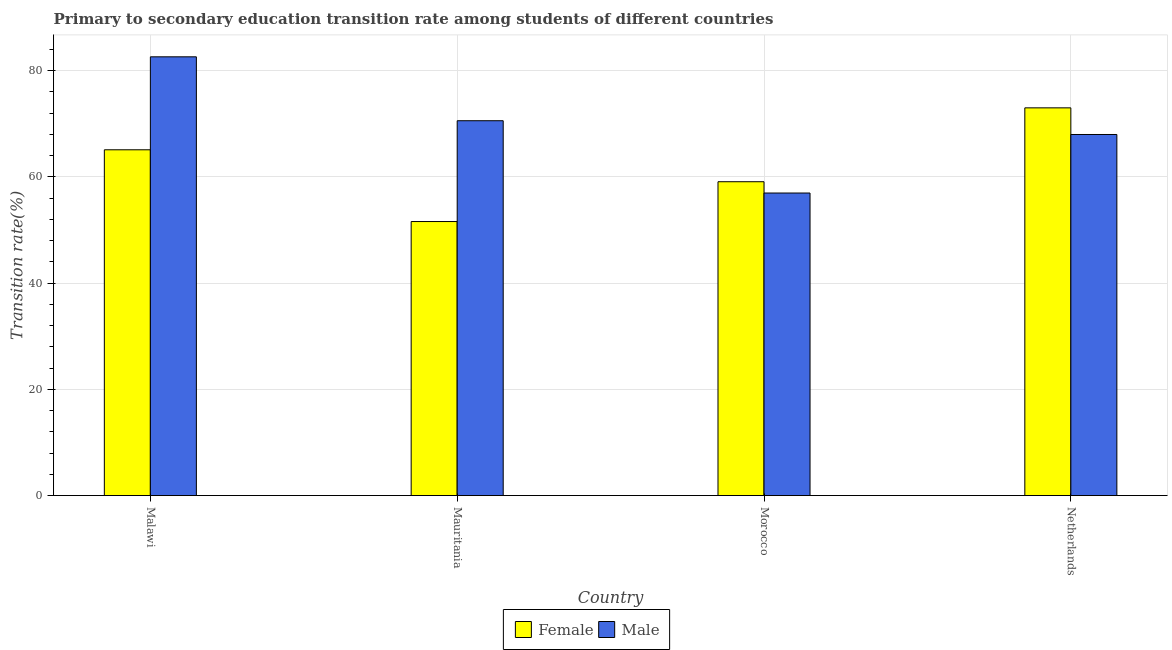How many different coloured bars are there?
Your answer should be compact. 2. Are the number of bars on each tick of the X-axis equal?
Offer a terse response. Yes. How many bars are there on the 2nd tick from the right?
Give a very brief answer. 2. What is the label of the 1st group of bars from the left?
Offer a terse response. Malawi. In how many cases, is the number of bars for a given country not equal to the number of legend labels?
Ensure brevity in your answer.  0. What is the transition rate among female students in Mauritania?
Keep it short and to the point. 51.59. Across all countries, what is the maximum transition rate among female students?
Ensure brevity in your answer.  73. Across all countries, what is the minimum transition rate among male students?
Provide a succinct answer. 56.96. In which country was the transition rate among female students maximum?
Offer a very short reply. Netherlands. In which country was the transition rate among male students minimum?
Your answer should be compact. Morocco. What is the total transition rate among female students in the graph?
Keep it short and to the point. 248.77. What is the difference between the transition rate among male students in Malawi and that in Mauritania?
Your answer should be compact. 12.03. What is the difference between the transition rate among female students in Netherlands and the transition rate among male students in Morocco?
Keep it short and to the point. 16.04. What is the average transition rate among male students per country?
Keep it short and to the point. 69.53. What is the difference between the transition rate among male students and transition rate among female students in Netherlands?
Keep it short and to the point. -5.02. In how many countries, is the transition rate among male students greater than 4 %?
Your answer should be very brief. 4. What is the ratio of the transition rate among female students in Malawi to that in Netherlands?
Make the answer very short. 0.89. Is the transition rate among female students in Malawi less than that in Morocco?
Your response must be concise. No. Is the difference between the transition rate among female students in Mauritania and Netherlands greater than the difference between the transition rate among male students in Mauritania and Netherlands?
Provide a short and direct response. No. What is the difference between the highest and the second highest transition rate among female students?
Give a very brief answer. 7.9. What is the difference between the highest and the lowest transition rate among male students?
Ensure brevity in your answer.  25.65. In how many countries, is the transition rate among male students greater than the average transition rate among male students taken over all countries?
Your answer should be very brief. 2. What does the 1st bar from the right in Mauritania represents?
Keep it short and to the point. Male. Are all the bars in the graph horizontal?
Your response must be concise. No. Are the values on the major ticks of Y-axis written in scientific E-notation?
Provide a short and direct response. No. Does the graph contain any zero values?
Give a very brief answer. No. Where does the legend appear in the graph?
Keep it short and to the point. Bottom center. How many legend labels are there?
Your response must be concise. 2. What is the title of the graph?
Give a very brief answer. Primary to secondary education transition rate among students of different countries. What is the label or title of the X-axis?
Offer a very short reply. Country. What is the label or title of the Y-axis?
Your answer should be compact. Transition rate(%). What is the Transition rate(%) in Female in Malawi?
Make the answer very short. 65.1. What is the Transition rate(%) of Male in Malawi?
Offer a terse response. 82.6. What is the Transition rate(%) of Female in Mauritania?
Your response must be concise. 51.59. What is the Transition rate(%) of Male in Mauritania?
Your answer should be very brief. 70.57. What is the Transition rate(%) in Female in Morocco?
Offer a terse response. 59.09. What is the Transition rate(%) in Male in Morocco?
Your response must be concise. 56.96. What is the Transition rate(%) in Female in Netherlands?
Give a very brief answer. 73. What is the Transition rate(%) of Male in Netherlands?
Provide a short and direct response. 67.98. Across all countries, what is the maximum Transition rate(%) in Female?
Offer a terse response. 73. Across all countries, what is the maximum Transition rate(%) in Male?
Ensure brevity in your answer.  82.6. Across all countries, what is the minimum Transition rate(%) in Female?
Your answer should be compact. 51.59. Across all countries, what is the minimum Transition rate(%) in Male?
Ensure brevity in your answer.  56.96. What is the total Transition rate(%) in Female in the graph?
Provide a succinct answer. 248.77. What is the total Transition rate(%) in Male in the graph?
Offer a very short reply. 278.11. What is the difference between the Transition rate(%) of Female in Malawi and that in Mauritania?
Offer a terse response. 13.51. What is the difference between the Transition rate(%) in Male in Malawi and that in Mauritania?
Offer a very short reply. 12.03. What is the difference between the Transition rate(%) of Female in Malawi and that in Morocco?
Give a very brief answer. 6.01. What is the difference between the Transition rate(%) in Male in Malawi and that in Morocco?
Your response must be concise. 25.65. What is the difference between the Transition rate(%) of Female in Malawi and that in Netherlands?
Make the answer very short. -7.9. What is the difference between the Transition rate(%) of Male in Malawi and that in Netherlands?
Your answer should be very brief. 14.63. What is the difference between the Transition rate(%) of Female in Mauritania and that in Morocco?
Offer a very short reply. -7.5. What is the difference between the Transition rate(%) of Male in Mauritania and that in Morocco?
Your answer should be very brief. 13.61. What is the difference between the Transition rate(%) of Female in Mauritania and that in Netherlands?
Your answer should be very brief. -21.41. What is the difference between the Transition rate(%) in Male in Mauritania and that in Netherlands?
Your response must be concise. 2.59. What is the difference between the Transition rate(%) of Female in Morocco and that in Netherlands?
Offer a very short reply. -13.91. What is the difference between the Transition rate(%) of Male in Morocco and that in Netherlands?
Ensure brevity in your answer.  -11.02. What is the difference between the Transition rate(%) of Female in Malawi and the Transition rate(%) of Male in Mauritania?
Provide a succinct answer. -5.47. What is the difference between the Transition rate(%) in Female in Malawi and the Transition rate(%) in Male in Morocco?
Offer a terse response. 8.14. What is the difference between the Transition rate(%) in Female in Malawi and the Transition rate(%) in Male in Netherlands?
Provide a short and direct response. -2.88. What is the difference between the Transition rate(%) in Female in Mauritania and the Transition rate(%) in Male in Morocco?
Your answer should be compact. -5.37. What is the difference between the Transition rate(%) in Female in Mauritania and the Transition rate(%) in Male in Netherlands?
Your answer should be very brief. -16.39. What is the difference between the Transition rate(%) of Female in Morocco and the Transition rate(%) of Male in Netherlands?
Your answer should be compact. -8.89. What is the average Transition rate(%) of Female per country?
Your answer should be very brief. 62.19. What is the average Transition rate(%) of Male per country?
Make the answer very short. 69.53. What is the difference between the Transition rate(%) in Female and Transition rate(%) in Male in Malawi?
Your response must be concise. -17.5. What is the difference between the Transition rate(%) in Female and Transition rate(%) in Male in Mauritania?
Provide a succinct answer. -18.98. What is the difference between the Transition rate(%) of Female and Transition rate(%) of Male in Morocco?
Your answer should be very brief. 2.13. What is the difference between the Transition rate(%) of Female and Transition rate(%) of Male in Netherlands?
Make the answer very short. 5.02. What is the ratio of the Transition rate(%) in Female in Malawi to that in Mauritania?
Your answer should be very brief. 1.26. What is the ratio of the Transition rate(%) in Male in Malawi to that in Mauritania?
Your answer should be compact. 1.17. What is the ratio of the Transition rate(%) of Female in Malawi to that in Morocco?
Your answer should be very brief. 1.1. What is the ratio of the Transition rate(%) of Male in Malawi to that in Morocco?
Provide a succinct answer. 1.45. What is the ratio of the Transition rate(%) in Female in Malawi to that in Netherlands?
Keep it short and to the point. 0.89. What is the ratio of the Transition rate(%) of Male in Malawi to that in Netherlands?
Provide a succinct answer. 1.22. What is the ratio of the Transition rate(%) in Female in Mauritania to that in Morocco?
Ensure brevity in your answer.  0.87. What is the ratio of the Transition rate(%) in Male in Mauritania to that in Morocco?
Give a very brief answer. 1.24. What is the ratio of the Transition rate(%) in Female in Mauritania to that in Netherlands?
Offer a terse response. 0.71. What is the ratio of the Transition rate(%) of Male in Mauritania to that in Netherlands?
Your answer should be very brief. 1.04. What is the ratio of the Transition rate(%) in Female in Morocco to that in Netherlands?
Keep it short and to the point. 0.81. What is the ratio of the Transition rate(%) in Male in Morocco to that in Netherlands?
Ensure brevity in your answer.  0.84. What is the difference between the highest and the second highest Transition rate(%) of Female?
Make the answer very short. 7.9. What is the difference between the highest and the second highest Transition rate(%) of Male?
Offer a terse response. 12.03. What is the difference between the highest and the lowest Transition rate(%) in Female?
Your response must be concise. 21.41. What is the difference between the highest and the lowest Transition rate(%) of Male?
Your response must be concise. 25.65. 